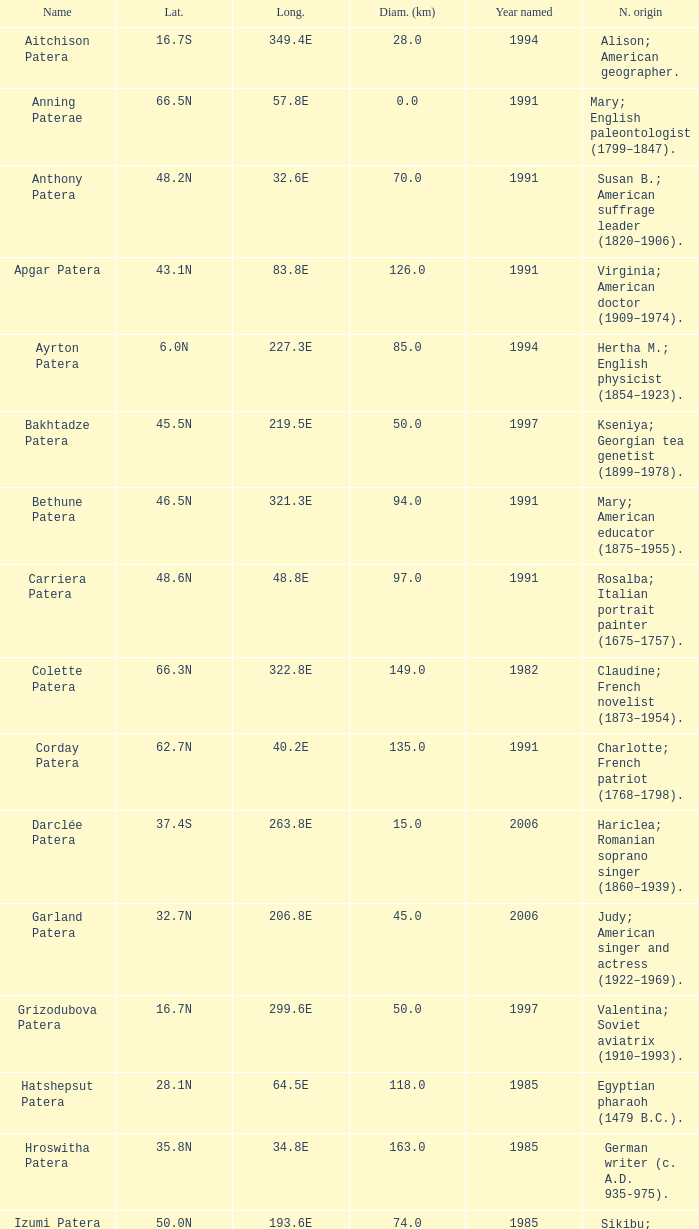In what year was the feature at a 33.3S latitude named?  2000.0. 